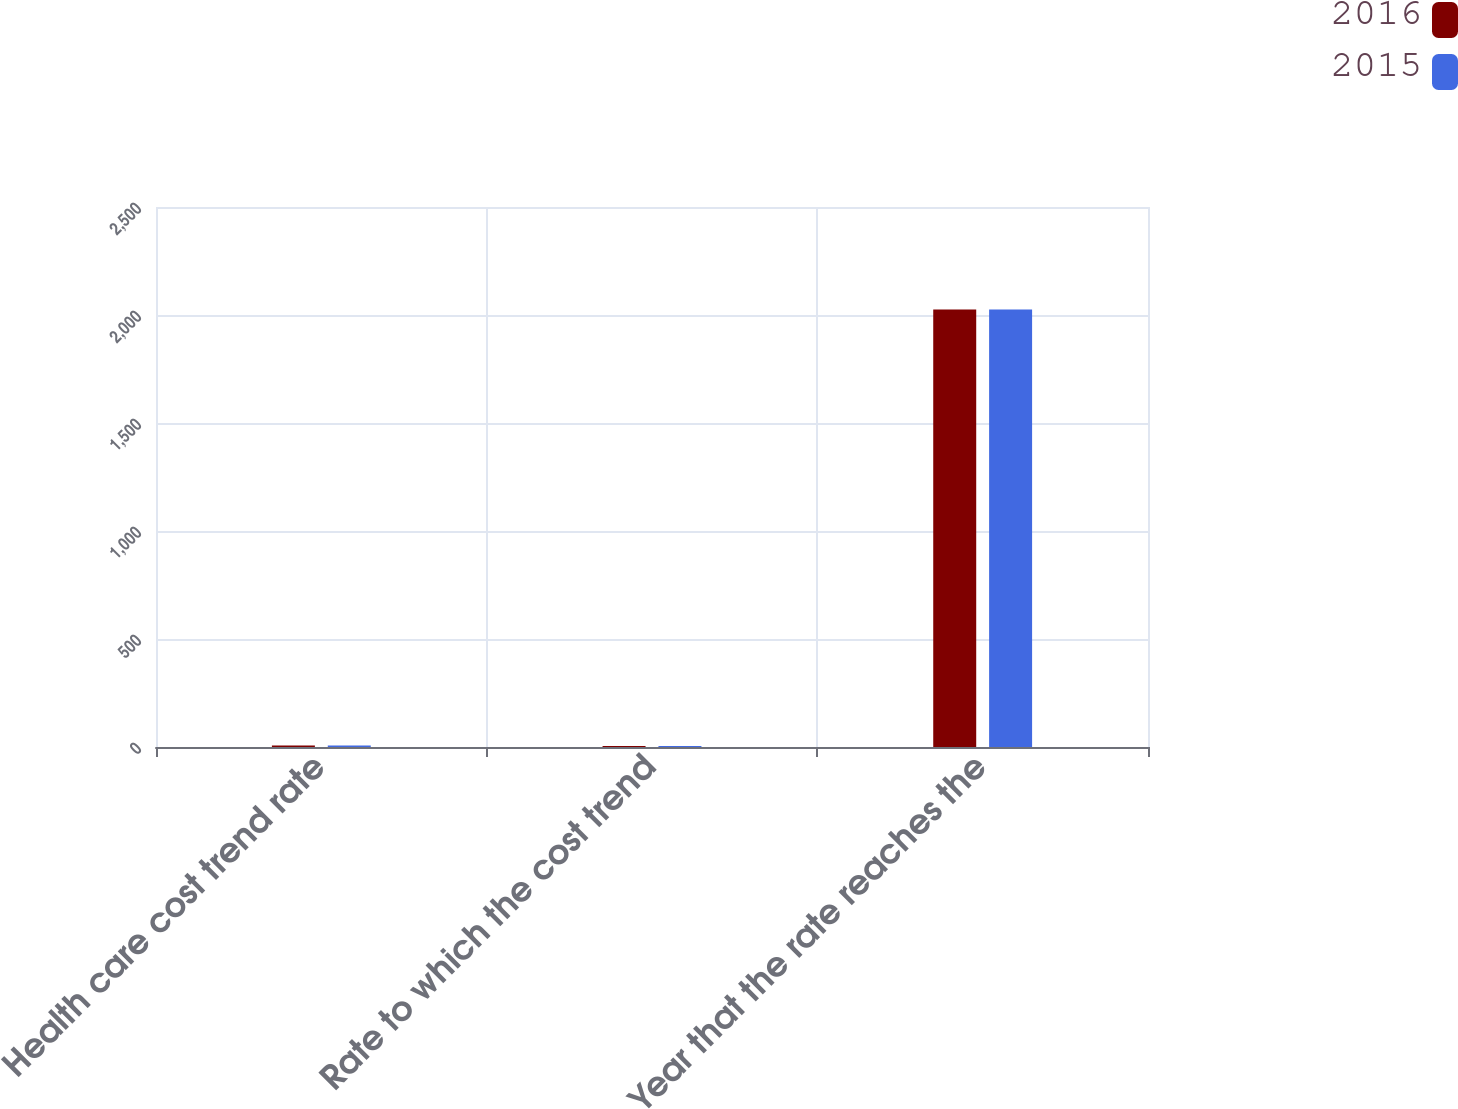Convert chart to OTSL. <chart><loc_0><loc_0><loc_500><loc_500><stacked_bar_chart><ecel><fcel>Health care cost trend rate<fcel>Rate to which the cost trend<fcel>Year that the rate reaches the<nl><fcel>2016<fcel>7.28<fcel>5<fcel>2026<nl><fcel>2015<fcel>7.29<fcel>5<fcel>2026<nl></chart> 